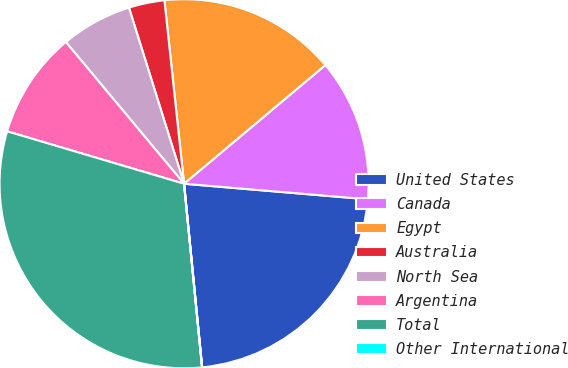Convert chart. <chart><loc_0><loc_0><loc_500><loc_500><pie_chart><fcel>United States<fcel>Canada<fcel>Egypt<fcel>Australia<fcel>North Sea<fcel>Argentina<fcel>Total<fcel>Other International<nl><fcel>22.09%<fcel>12.46%<fcel>15.58%<fcel>3.13%<fcel>6.24%<fcel>9.35%<fcel>31.14%<fcel>0.01%<nl></chart> 